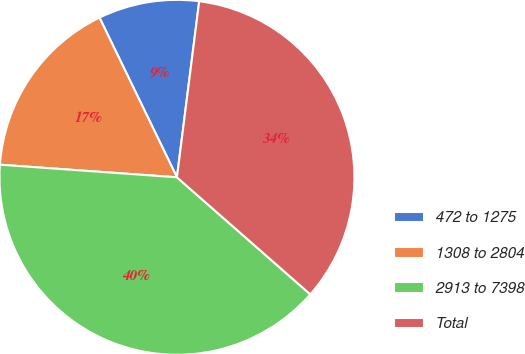Convert chart to OTSL. <chart><loc_0><loc_0><loc_500><loc_500><pie_chart><fcel>472 to 1275<fcel>1308 to 2804<fcel>2913 to 7398<fcel>Total<nl><fcel>9.19%<fcel>16.68%<fcel>39.67%<fcel>34.46%<nl></chart> 